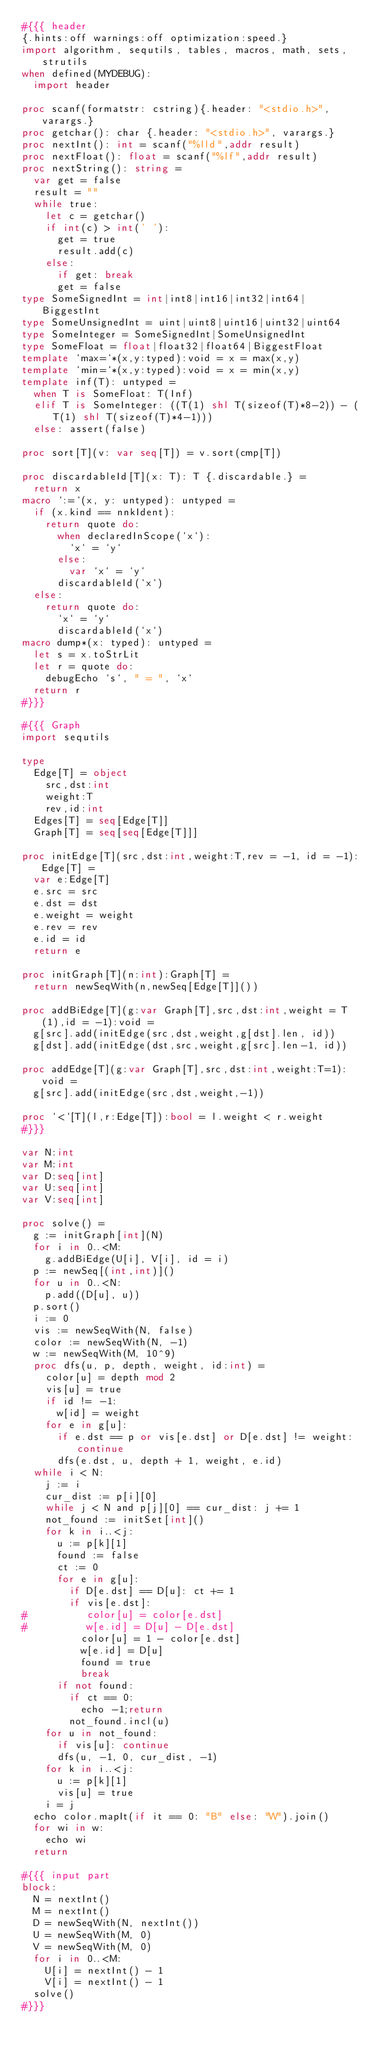Convert code to text. <code><loc_0><loc_0><loc_500><loc_500><_Nim_>#{{{ header
{.hints:off warnings:off optimization:speed.}
import algorithm, sequtils, tables, macros, math, sets, strutils
when defined(MYDEBUG):
  import header

proc scanf(formatstr: cstring){.header: "<stdio.h>", varargs.}
proc getchar(): char {.header: "<stdio.h>", varargs.}
proc nextInt(): int = scanf("%lld",addr result)
proc nextFloat(): float = scanf("%lf",addr result)
proc nextString(): string =
  var get = false
  result = ""
  while true:
    let c = getchar()
    if int(c) > int(' '):
      get = true
      result.add(c)
    else:
      if get: break
      get = false
type SomeSignedInt = int|int8|int16|int32|int64|BiggestInt
type SomeUnsignedInt = uint|uint8|uint16|uint32|uint64
type SomeInteger = SomeSignedInt|SomeUnsignedInt
type SomeFloat = float|float32|float64|BiggestFloat
template `max=`*(x,y:typed):void = x = max(x,y)
template `min=`*(x,y:typed):void = x = min(x,y)
template inf(T): untyped = 
  when T is SomeFloat: T(Inf)
  elif T is SomeInteger: ((T(1) shl T(sizeof(T)*8-2)) - (T(1) shl T(sizeof(T)*4-1)))
  else: assert(false)

proc sort[T](v: var seq[T]) = v.sort(cmp[T])

proc discardableId[T](x: T): T {.discardable.} =
  return x
macro `:=`(x, y: untyped): untyped =
  if (x.kind == nnkIdent):
    return quote do:
      when declaredInScope(`x`):
        `x` = `y`
      else:
        var `x` = `y`
      discardableId(`x`)
  else:
    return quote do:
      `x` = `y`
      discardableId(`x`)
macro dump*(x: typed): untyped =
  let s = x.toStrLit
  let r = quote do:
    debugEcho `s`, " = ", `x`
  return r
#}}}

#{{{ Graph
import sequtils

type
  Edge[T] = object
    src,dst:int
    weight:T
    rev,id:int
  Edges[T] = seq[Edge[T]]
  Graph[T] = seq[seq[Edge[T]]]

proc initEdge[T](src,dst:int,weight:T,rev = -1, id = -1):Edge[T] =
  var e:Edge[T]
  e.src = src
  e.dst = dst
  e.weight = weight
  e.rev = rev
  e.id = id
  return e

proc initGraph[T](n:int):Graph[T] =
  return newSeqWith(n,newSeq[Edge[T]]())

proc addBiEdge[T](g:var Graph[T],src,dst:int,weight = T(1),id = -1):void =
  g[src].add(initEdge(src,dst,weight,g[dst].len, id))
  g[dst].add(initEdge(dst,src,weight,g[src].len-1, id))

proc addEdge[T](g:var Graph[T],src,dst:int,weight:T=1):void =
  g[src].add(initEdge(src,dst,weight,-1))

proc `<`[T](l,r:Edge[T]):bool = l.weight < r.weight
#}}}

var N:int
var M:int
var D:seq[int]
var U:seq[int]
var V:seq[int]

proc solve() =
  g := initGraph[int](N)
  for i in 0..<M:
    g.addBiEdge(U[i], V[i], id = i)
  p := newSeq[(int,int)]()
  for u in 0..<N:
    p.add((D[u], u))
  p.sort()
  i := 0
  vis := newSeqWith(N, false)
  color := newSeqWith(N, -1)
  w := newSeqWith(M, 10^9)
  proc dfs(u, p, depth, weight, id:int) =
    color[u] = depth mod 2
    vis[u] = true
    if id != -1:
      w[id] = weight
    for e in g[u]:
      if e.dst == p or vis[e.dst] or D[e.dst] != weight: continue
      dfs(e.dst, u, depth + 1, weight, e.id)
  while i < N:
    j := i
    cur_dist := p[i][0]
    while j < N and p[j][0] == cur_dist: j += 1
    not_found := initSet[int]()
    for k in i..<j:
      u := p[k][1]
      found := false
      ct := 0
      for e in g[u]:
        if D[e.dst] == D[u]: ct += 1
        if vis[e.dst]:
#          color[u] = color[e.dst]
#          w[e.id] = D[u] - D[e.dst]
          color[u] = 1 - color[e.dst]
          w[e.id] = D[u]
          found = true
          break
      if not found:
        if ct == 0:
          echo -1;return
        not_found.incl(u)
    for u in not_found:
      if vis[u]: continue
      dfs(u, -1, 0, cur_dist, -1)
    for k in i..<j:
      u := p[k][1]
      vis[u] = true
    i = j
  echo color.mapIt(if it == 0: "B" else: "W").join()
  for wi in w:
    echo wi
  return

#{{{ input part
block:
  N = nextInt()
  M = nextInt()
  D = newSeqWith(N, nextInt())
  U = newSeqWith(M, 0)
  V = newSeqWith(M, 0)
  for i in 0..<M:
    U[i] = nextInt() - 1
    V[i] = nextInt() - 1
  solve()
#}}}</code> 